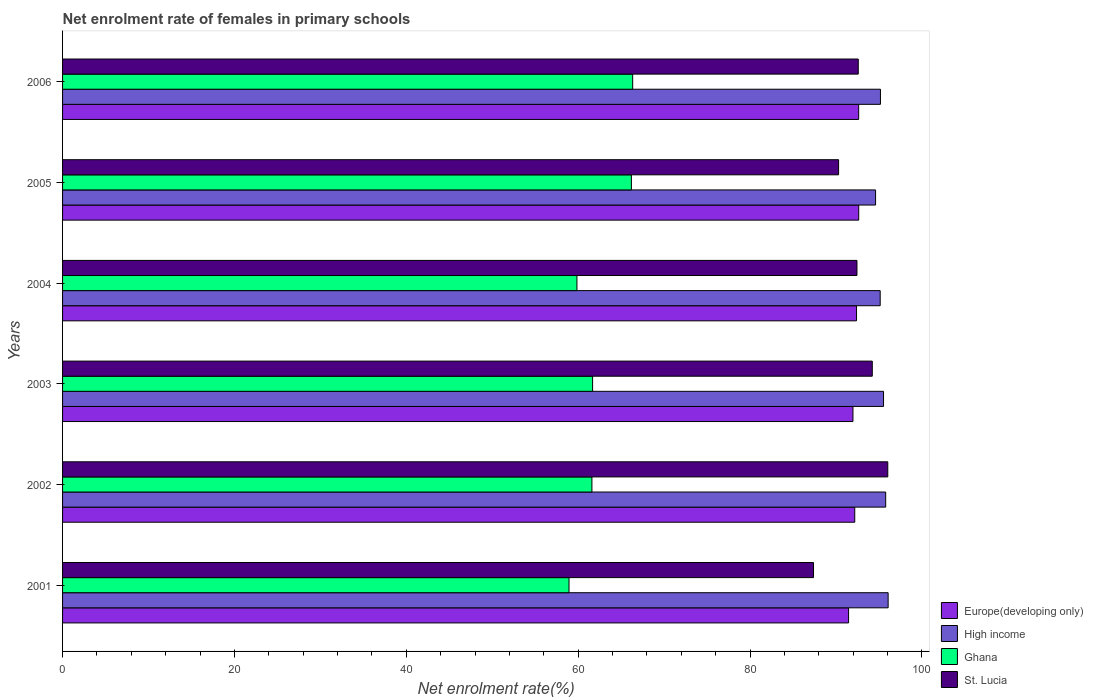How many different coloured bars are there?
Offer a very short reply. 4. Are the number of bars per tick equal to the number of legend labels?
Your answer should be compact. Yes. What is the net enrolment rate of females in primary schools in St. Lucia in 2004?
Ensure brevity in your answer.  92.44. Across all years, what is the maximum net enrolment rate of females in primary schools in High income?
Offer a very short reply. 96.07. Across all years, what is the minimum net enrolment rate of females in primary schools in High income?
Give a very brief answer. 94.61. In which year was the net enrolment rate of females in primary schools in Ghana maximum?
Give a very brief answer. 2006. In which year was the net enrolment rate of females in primary schools in Ghana minimum?
Give a very brief answer. 2001. What is the total net enrolment rate of females in primary schools in Europe(developing only) in the graph?
Provide a succinct answer. 553.29. What is the difference between the net enrolment rate of females in primary schools in Ghana in 2002 and that in 2004?
Ensure brevity in your answer.  1.74. What is the difference between the net enrolment rate of females in primary schools in Ghana in 2004 and the net enrolment rate of females in primary schools in St. Lucia in 2006?
Your answer should be compact. -32.74. What is the average net enrolment rate of females in primary schools in St. Lucia per year?
Offer a terse response. 92.16. In the year 2002, what is the difference between the net enrolment rate of females in primary schools in Ghana and net enrolment rate of females in primary schools in Europe(developing only)?
Provide a short and direct response. -30.58. In how many years, is the net enrolment rate of females in primary schools in Ghana greater than 64 %?
Make the answer very short. 2. What is the ratio of the net enrolment rate of females in primary schools in Europe(developing only) in 2002 to that in 2004?
Provide a short and direct response. 1. Is the net enrolment rate of females in primary schools in Europe(developing only) in 2004 less than that in 2005?
Ensure brevity in your answer.  Yes. Is the difference between the net enrolment rate of females in primary schools in Ghana in 2001 and 2003 greater than the difference between the net enrolment rate of females in primary schools in Europe(developing only) in 2001 and 2003?
Your response must be concise. No. What is the difference between the highest and the second highest net enrolment rate of females in primary schools in High income?
Offer a very short reply. 0.29. What is the difference between the highest and the lowest net enrolment rate of females in primary schools in Europe(developing only)?
Make the answer very short. 1.18. What does the 1st bar from the bottom in 2006 represents?
Offer a very short reply. Europe(developing only). Is it the case that in every year, the sum of the net enrolment rate of females in primary schools in Europe(developing only) and net enrolment rate of females in primary schools in St. Lucia is greater than the net enrolment rate of females in primary schools in Ghana?
Your answer should be compact. Yes. How many years are there in the graph?
Make the answer very short. 6. Does the graph contain any zero values?
Give a very brief answer. No. How many legend labels are there?
Make the answer very short. 4. How are the legend labels stacked?
Your answer should be very brief. Vertical. What is the title of the graph?
Give a very brief answer. Net enrolment rate of females in primary schools. Does "Bahrain" appear as one of the legend labels in the graph?
Keep it short and to the point. No. What is the label or title of the X-axis?
Your response must be concise. Net enrolment rate(%). What is the label or title of the Y-axis?
Offer a terse response. Years. What is the Net enrolment rate(%) of Europe(developing only) in 2001?
Ensure brevity in your answer.  91.46. What is the Net enrolment rate(%) of High income in 2001?
Your answer should be very brief. 96.07. What is the Net enrolment rate(%) in Ghana in 2001?
Ensure brevity in your answer.  58.93. What is the Net enrolment rate(%) of St. Lucia in 2001?
Offer a very short reply. 87.38. What is the Net enrolment rate(%) in Europe(developing only) in 2002?
Make the answer very short. 92.18. What is the Net enrolment rate(%) of High income in 2002?
Offer a very short reply. 95.78. What is the Net enrolment rate(%) of Ghana in 2002?
Give a very brief answer. 61.6. What is the Net enrolment rate(%) in St. Lucia in 2002?
Provide a short and direct response. 96.03. What is the Net enrolment rate(%) of Europe(developing only) in 2003?
Give a very brief answer. 91.97. What is the Net enrolment rate(%) of High income in 2003?
Give a very brief answer. 95.53. What is the Net enrolment rate(%) in Ghana in 2003?
Your answer should be very brief. 61.68. What is the Net enrolment rate(%) of St. Lucia in 2003?
Offer a terse response. 94.22. What is the Net enrolment rate(%) of Europe(developing only) in 2004?
Ensure brevity in your answer.  92.39. What is the Net enrolment rate(%) in High income in 2004?
Offer a very short reply. 95.14. What is the Net enrolment rate(%) of Ghana in 2004?
Keep it short and to the point. 59.85. What is the Net enrolment rate(%) in St. Lucia in 2004?
Offer a terse response. 92.44. What is the Net enrolment rate(%) of Europe(developing only) in 2005?
Give a very brief answer. 92.64. What is the Net enrolment rate(%) of High income in 2005?
Keep it short and to the point. 94.61. What is the Net enrolment rate(%) of Ghana in 2005?
Provide a short and direct response. 66.19. What is the Net enrolment rate(%) of St. Lucia in 2005?
Your answer should be very brief. 90.3. What is the Net enrolment rate(%) in Europe(developing only) in 2006?
Keep it short and to the point. 92.64. What is the Net enrolment rate(%) of High income in 2006?
Your answer should be compact. 95.17. What is the Net enrolment rate(%) of Ghana in 2006?
Your answer should be very brief. 66.34. What is the Net enrolment rate(%) of St. Lucia in 2006?
Offer a very short reply. 92.59. Across all years, what is the maximum Net enrolment rate(%) in Europe(developing only)?
Provide a short and direct response. 92.64. Across all years, what is the maximum Net enrolment rate(%) of High income?
Give a very brief answer. 96.07. Across all years, what is the maximum Net enrolment rate(%) of Ghana?
Provide a short and direct response. 66.34. Across all years, what is the maximum Net enrolment rate(%) in St. Lucia?
Keep it short and to the point. 96.03. Across all years, what is the minimum Net enrolment rate(%) in Europe(developing only)?
Provide a short and direct response. 91.46. Across all years, what is the minimum Net enrolment rate(%) in High income?
Your answer should be very brief. 94.61. Across all years, what is the minimum Net enrolment rate(%) of Ghana?
Your answer should be very brief. 58.93. Across all years, what is the minimum Net enrolment rate(%) in St. Lucia?
Keep it short and to the point. 87.38. What is the total Net enrolment rate(%) in Europe(developing only) in the graph?
Your answer should be compact. 553.29. What is the total Net enrolment rate(%) in High income in the graph?
Provide a succinct answer. 572.3. What is the total Net enrolment rate(%) of Ghana in the graph?
Offer a very short reply. 374.59. What is the total Net enrolment rate(%) in St. Lucia in the graph?
Provide a short and direct response. 552.96. What is the difference between the Net enrolment rate(%) in Europe(developing only) in 2001 and that in 2002?
Give a very brief answer. -0.72. What is the difference between the Net enrolment rate(%) of High income in 2001 and that in 2002?
Your answer should be very brief. 0.29. What is the difference between the Net enrolment rate(%) in Ghana in 2001 and that in 2002?
Make the answer very short. -2.67. What is the difference between the Net enrolment rate(%) in St. Lucia in 2001 and that in 2002?
Your answer should be very brief. -8.64. What is the difference between the Net enrolment rate(%) in Europe(developing only) in 2001 and that in 2003?
Give a very brief answer. -0.51. What is the difference between the Net enrolment rate(%) in High income in 2001 and that in 2003?
Offer a very short reply. 0.54. What is the difference between the Net enrolment rate(%) in Ghana in 2001 and that in 2003?
Your answer should be compact. -2.74. What is the difference between the Net enrolment rate(%) in St. Lucia in 2001 and that in 2003?
Make the answer very short. -6.84. What is the difference between the Net enrolment rate(%) of Europe(developing only) in 2001 and that in 2004?
Your response must be concise. -0.93. What is the difference between the Net enrolment rate(%) of High income in 2001 and that in 2004?
Ensure brevity in your answer.  0.93. What is the difference between the Net enrolment rate(%) in Ghana in 2001 and that in 2004?
Provide a succinct answer. -0.92. What is the difference between the Net enrolment rate(%) of St. Lucia in 2001 and that in 2004?
Ensure brevity in your answer.  -5.06. What is the difference between the Net enrolment rate(%) in Europe(developing only) in 2001 and that in 2005?
Make the answer very short. -1.18. What is the difference between the Net enrolment rate(%) of High income in 2001 and that in 2005?
Make the answer very short. 1.46. What is the difference between the Net enrolment rate(%) of Ghana in 2001 and that in 2005?
Your answer should be compact. -7.26. What is the difference between the Net enrolment rate(%) in St. Lucia in 2001 and that in 2005?
Your answer should be compact. -2.92. What is the difference between the Net enrolment rate(%) in Europe(developing only) in 2001 and that in 2006?
Provide a succinct answer. -1.18. What is the difference between the Net enrolment rate(%) in High income in 2001 and that in 2006?
Provide a short and direct response. 0.89. What is the difference between the Net enrolment rate(%) of Ghana in 2001 and that in 2006?
Your response must be concise. -7.41. What is the difference between the Net enrolment rate(%) of St. Lucia in 2001 and that in 2006?
Ensure brevity in your answer.  -5.21. What is the difference between the Net enrolment rate(%) in Europe(developing only) in 2002 and that in 2003?
Provide a short and direct response. 0.21. What is the difference between the Net enrolment rate(%) of High income in 2002 and that in 2003?
Provide a succinct answer. 0.25. What is the difference between the Net enrolment rate(%) in Ghana in 2002 and that in 2003?
Your response must be concise. -0.08. What is the difference between the Net enrolment rate(%) of St. Lucia in 2002 and that in 2003?
Provide a succinct answer. 1.8. What is the difference between the Net enrolment rate(%) in Europe(developing only) in 2002 and that in 2004?
Give a very brief answer. -0.21. What is the difference between the Net enrolment rate(%) in High income in 2002 and that in 2004?
Offer a very short reply. 0.64. What is the difference between the Net enrolment rate(%) in Ghana in 2002 and that in 2004?
Offer a terse response. 1.74. What is the difference between the Net enrolment rate(%) of St. Lucia in 2002 and that in 2004?
Keep it short and to the point. 3.59. What is the difference between the Net enrolment rate(%) of Europe(developing only) in 2002 and that in 2005?
Your answer should be very brief. -0.46. What is the difference between the Net enrolment rate(%) of High income in 2002 and that in 2005?
Your answer should be very brief. 1.18. What is the difference between the Net enrolment rate(%) of Ghana in 2002 and that in 2005?
Keep it short and to the point. -4.59. What is the difference between the Net enrolment rate(%) in St. Lucia in 2002 and that in 2005?
Offer a very short reply. 5.72. What is the difference between the Net enrolment rate(%) in Europe(developing only) in 2002 and that in 2006?
Keep it short and to the point. -0.46. What is the difference between the Net enrolment rate(%) in High income in 2002 and that in 2006?
Your answer should be very brief. 0.61. What is the difference between the Net enrolment rate(%) in Ghana in 2002 and that in 2006?
Provide a short and direct response. -4.74. What is the difference between the Net enrolment rate(%) in St. Lucia in 2002 and that in 2006?
Make the answer very short. 3.44. What is the difference between the Net enrolment rate(%) of Europe(developing only) in 2003 and that in 2004?
Give a very brief answer. -0.42. What is the difference between the Net enrolment rate(%) in High income in 2003 and that in 2004?
Provide a succinct answer. 0.39. What is the difference between the Net enrolment rate(%) of Ghana in 2003 and that in 2004?
Make the answer very short. 1.82. What is the difference between the Net enrolment rate(%) in St. Lucia in 2003 and that in 2004?
Provide a succinct answer. 1.78. What is the difference between the Net enrolment rate(%) in Europe(developing only) in 2003 and that in 2005?
Make the answer very short. -0.67. What is the difference between the Net enrolment rate(%) in High income in 2003 and that in 2005?
Keep it short and to the point. 0.92. What is the difference between the Net enrolment rate(%) of Ghana in 2003 and that in 2005?
Keep it short and to the point. -4.51. What is the difference between the Net enrolment rate(%) in St. Lucia in 2003 and that in 2005?
Offer a terse response. 3.92. What is the difference between the Net enrolment rate(%) of Europe(developing only) in 2003 and that in 2006?
Give a very brief answer. -0.67. What is the difference between the Net enrolment rate(%) in High income in 2003 and that in 2006?
Your answer should be very brief. 0.36. What is the difference between the Net enrolment rate(%) of Ghana in 2003 and that in 2006?
Provide a short and direct response. -4.66. What is the difference between the Net enrolment rate(%) of St. Lucia in 2003 and that in 2006?
Give a very brief answer. 1.63. What is the difference between the Net enrolment rate(%) in Europe(developing only) in 2004 and that in 2005?
Make the answer very short. -0.25. What is the difference between the Net enrolment rate(%) in High income in 2004 and that in 2005?
Ensure brevity in your answer.  0.54. What is the difference between the Net enrolment rate(%) of Ghana in 2004 and that in 2005?
Ensure brevity in your answer.  -6.34. What is the difference between the Net enrolment rate(%) in St. Lucia in 2004 and that in 2005?
Your answer should be compact. 2.14. What is the difference between the Net enrolment rate(%) of Europe(developing only) in 2004 and that in 2006?
Your response must be concise. -0.25. What is the difference between the Net enrolment rate(%) of High income in 2004 and that in 2006?
Offer a very short reply. -0.03. What is the difference between the Net enrolment rate(%) of Ghana in 2004 and that in 2006?
Offer a terse response. -6.49. What is the difference between the Net enrolment rate(%) in St. Lucia in 2004 and that in 2006?
Provide a succinct answer. -0.15. What is the difference between the Net enrolment rate(%) in Europe(developing only) in 2005 and that in 2006?
Keep it short and to the point. 0. What is the difference between the Net enrolment rate(%) of High income in 2005 and that in 2006?
Ensure brevity in your answer.  -0.57. What is the difference between the Net enrolment rate(%) in Ghana in 2005 and that in 2006?
Offer a terse response. -0.15. What is the difference between the Net enrolment rate(%) in St. Lucia in 2005 and that in 2006?
Make the answer very short. -2.29. What is the difference between the Net enrolment rate(%) of Europe(developing only) in 2001 and the Net enrolment rate(%) of High income in 2002?
Your answer should be compact. -4.32. What is the difference between the Net enrolment rate(%) of Europe(developing only) in 2001 and the Net enrolment rate(%) of Ghana in 2002?
Provide a short and direct response. 29.86. What is the difference between the Net enrolment rate(%) in Europe(developing only) in 2001 and the Net enrolment rate(%) in St. Lucia in 2002?
Provide a short and direct response. -4.56. What is the difference between the Net enrolment rate(%) of High income in 2001 and the Net enrolment rate(%) of Ghana in 2002?
Your answer should be compact. 34.47. What is the difference between the Net enrolment rate(%) in High income in 2001 and the Net enrolment rate(%) in St. Lucia in 2002?
Your response must be concise. 0.04. What is the difference between the Net enrolment rate(%) in Ghana in 2001 and the Net enrolment rate(%) in St. Lucia in 2002?
Your answer should be very brief. -37.09. What is the difference between the Net enrolment rate(%) in Europe(developing only) in 2001 and the Net enrolment rate(%) in High income in 2003?
Ensure brevity in your answer.  -4.07. What is the difference between the Net enrolment rate(%) of Europe(developing only) in 2001 and the Net enrolment rate(%) of Ghana in 2003?
Keep it short and to the point. 29.79. What is the difference between the Net enrolment rate(%) in Europe(developing only) in 2001 and the Net enrolment rate(%) in St. Lucia in 2003?
Your answer should be very brief. -2.76. What is the difference between the Net enrolment rate(%) in High income in 2001 and the Net enrolment rate(%) in Ghana in 2003?
Your answer should be compact. 34.39. What is the difference between the Net enrolment rate(%) in High income in 2001 and the Net enrolment rate(%) in St. Lucia in 2003?
Provide a short and direct response. 1.84. What is the difference between the Net enrolment rate(%) of Ghana in 2001 and the Net enrolment rate(%) of St. Lucia in 2003?
Provide a succinct answer. -35.29. What is the difference between the Net enrolment rate(%) in Europe(developing only) in 2001 and the Net enrolment rate(%) in High income in 2004?
Ensure brevity in your answer.  -3.68. What is the difference between the Net enrolment rate(%) in Europe(developing only) in 2001 and the Net enrolment rate(%) in Ghana in 2004?
Provide a short and direct response. 31.61. What is the difference between the Net enrolment rate(%) in Europe(developing only) in 2001 and the Net enrolment rate(%) in St. Lucia in 2004?
Your answer should be very brief. -0.98. What is the difference between the Net enrolment rate(%) in High income in 2001 and the Net enrolment rate(%) in Ghana in 2004?
Give a very brief answer. 36.21. What is the difference between the Net enrolment rate(%) of High income in 2001 and the Net enrolment rate(%) of St. Lucia in 2004?
Give a very brief answer. 3.63. What is the difference between the Net enrolment rate(%) of Ghana in 2001 and the Net enrolment rate(%) of St. Lucia in 2004?
Your answer should be compact. -33.51. What is the difference between the Net enrolment rate(%) in Europe(developing only) in 2001 and the Net enrolment rate(%) in High income in 2005?
Make the answer very short. -3.14. What is the difference between the Net enrolment rate(%) in Europe(developing only) in 2001 and the Net enrolment rate(%) in Ghana in 2005?
Give a very brief answer. 25.27. What is the difference between the Net enrolment rate(%) in Europe(developing only) in 2001 and the Net enrolment rate(%) in St. Lucia in 2005?
Provide a succinct answer. 1.16. What is the difference between the Net enrolment rate(%) of High income in 2001 and the Net enrolment rate(%) of Ghana in 2005?
Offer a very short reply. 29.88. What is the difference between the Net enrolment rate(%) of High income in 2001 and the Net enrolment rate(%) of St. Lucia in 2005?
Offer a terse response. 5.76. What is the difference between the Net enrolment rate(%) in Ghana in 2001 and the Net enrolment rate(%) in St. Lucia in 2005?
Make the answer very short. -31.37. What is the difference between the Net enrolment rate(%) of Europe(developing only) in 2001 and the Net enrolment rate(%) of High income in 2006?
Offer a terse response. -3.71. What is the difference between the Net enrolment rate(%) in Europe(developing only) in 2001 and the Net enrolment rate(%) in Ghana in 2006?
Keep it short and to the point. 25.12. What is the difference between the Net enrolment rate(%) of Europe(developing only) in 2001 and the Net enrolment rate(%) of St. Lucia in 2006?
Your response must be concise. -1.13. What is the difference between the Net enrolment rate(%) of High income in 2001 and the Net enrolment rate(%) of Ghana in 2006?
Your answer should be very brief. 29.73. What is the difference between the Net enrolment rate(%) in High income in 2001 and the Net enrolment rate(%) in St. Lucia in 2006?
Provide a short and direct response. 3.48. What is the difference between the Net enrolment rate(%) of Ghana in 2001 and the Net enrolment rate(%) of St. Lucia in 2006?
Give a very brief answer. -33.66. What is the difference between the Net enrolment rate(%) of Europe(developing only) in 2002 and the Net enrolment rate(%) of High income in 2003?
Your response must be concise. -3.35. What is the difference between the Net enrolment rate(%) of Europe(developing only) in 2002 and the Net enrolment rate(%) of Ghana in 2003?
Offer a terse response. 30.51. What is the difference between the Net enrolment rate(%) of Europe(developing only) in 2002 and the Net enrolment rate(%) of St. Lucia in 2003?
Give a very brief answer. -2.04. What is the difference between the Net enrolment rate(%) of High income in 2002 and the Net enrolment rate(%) of Ghana in 2003?
Your answer should be compact. 34.11. What is the difference between the Net enrolment rate(%) of High income in 2002 and the Net enrolment rate(%) of St. Lucia in 2003?
Make the answer very short. 1.56. What is the difference between the Net enrolment rate(%) in Ghana in 2002 and the Net enrolment rate(%) in St. Lucia in 2003?
Keep it short and to the point. -32.62. What is the difference between the Net enrolment rate(%) of Europe(developing only) in 2002 and the Net enrolment rate(%) of High income in 2004?
Provide a short and direct response. -2.96. What is the difference between the Net enrolment rate(%) of Europe(developing only) in 2002 and the Net enrolment rate(%) of Ghana in 2004?
Ensure brevity in your answer.  32.33. What is the difference between the Net enrolment rate(%) in Europe(developing only) in 2002 and the Net enrolment rate(%) in St. Lucia in 2004?
Offer a terse response. -0.26. What is the difference between the Net enrolment rate(%) in High income in 2002 and the Net enrolment rate(%) in Ghana in 2004?
Provide a short and direct response. 35.93. What is the difference between the Net enrolment rate(%) of High income in 2002 and the Net enrolment rate(%) of St. Lucia in 2004?
Offer a terse response. 3.34. What is the difference between the Net enrolment rate(%) of Ghana in 2002 and the Net enrolment rate(%) of St. Lucia in 2004?
Make the answer very short. -30.84. What is the difference between the Net enrolment rate(%) in Europe(developing only) in 2002 and the Net enrolment rate(%) in High income in 2005?
Ensure brevity in your answer.  -2.42. What is the difference between the Net enrolment rate(%) of Europe(developing only) in 2002 and the Net enrolment rate(%) of Ghana in 2005?
Provide a succinct answer. 25.99. What is the difference between the Net enrolment rate(%) of Europe(developing only) in 2002 and the Net enrolment rate(%) of St. Lucia in 2005?
Make the answer very short. 1.88. What is the difference between the Net enrolment rate(%) in High income in 2002 and the Net enrolment rate(%) in Ghana in 2005?
Your answer should be compact. 29.59. What is the difference between the Net enrolment rate(%) of High income in 2002 and the Net enrolment rate(%) of St. Lucia in 2005?
Offer a terse response. 5.48. What is the difference between the Net enrolment rate(%) of Ghana in 2002 and the Net enrolment rate(%) of St. Lucia in 2005?
Offer a terse response. -28.7. What is the difference between the Net enrolment rate(%) of Europe(developing only) in 2002 and the Net enrolment rate(%) of High income in 2006?
Offer a very short reply. -2.99. What is the difference between the Net enrolment rate(%) in Europe(developing only) in 2002 and the Net enrolment rate(%) in Ghana in 2006?
Your answer should be compact. 25.84. What is the difference between the Net enrolment rate(%) in Europe(developing only) in 2002 and the Net enrolment rate(%) in St. Lucia in 2006?
Your response must be concise. -0.41. What is the difference between the Net enrolment rate(%) of High income in 2002 and the Net enrolment rate(%) of Ghana in 2006?
Provide a succinct answer. 29.44. What is the difference between the Net enrolment rate(%) in High income in 2002 and the Net enrolment rate(%) in St. Lucia in 2006?
Offer a very short reply. 3.19. What is the difference between the Net enrolment rate(%) of Ghana in 2002 and the Net enrolment rate(%) of St. Lucia in 2006?
Keep it short and to the point. -30.99. What is the difference between the Net enrolment rate(%) in Europe(developing only) in 2003 and the Net enrolment rate(%) in High income in 2004?
Keep it short and to the point. -3.17. What is the difference between the Net enrolment rate(%) of Europe(developing only) in 2003 and the Net enrolment rate(%) of Ghana in 2004?
Provide a short and direct response. 32.12. What is the difference between the Net enrolment rate(%) of Europe(developing only) in 2003 and the Net enrolment rate(%) of St. Lucia in 2004?
Provide a short and direct response. -0.47. What is the difference between the Net enrolment rate(%) in High income in 2003 and the Net enrolment rate(%) in Ghana in 2004?
Ensure brevity in your answer.  35.68. What is the difference between the Net enrolment rate(%) of High income in 2003 and the Net enrolment rate(%) of St. Lucia in 2004?
Provide a short and direct response. 3.09. What is the difference between the Net enrolment rate(%) of Ghana in 2003 and the Net enrolment rate(%) of St. Lucia in 2004?
Offer a very short reply. -30.76. What is the difference between the Net enrolment rate(%) of Europe(developing only) in 2003 and the Net enrolment rate(%) of High income in 2005?
Keep it short and to the point. -2.63. What is the difference between the Net enrolment rate(%) of Europe(developing only) in 2003 and the Net enrolment rate(%) of Ghana in 2005?
Offer a very short reply. 25.78. What is the difference between the Net enrolment rate(%) of Europe(developing only) in 2003 and the Net enrolment rate(%) of St. Lucia in 2005?
Ensure brevity in your answer.  1.67. What is the difference between the Net enrolment rate(%) in High income in 2003 and the Net enrolment rate(%) in Ghana in 2005?
Your answer should be compact. 29.34. What is the difference between the Net enrolment rate(%) of High income in 2003 and the Net enrolment rate(%) of St. Lucia in 2005?
Your answer should be compact. 5.23. What is the difference between the Net enrolment rate(%) of Ghana in 2003 and the Net enrolment rate(%) of St. Lucia in 2005?
Provide a succinct answer. -28.63. What is the difference between the Net enrolment rate(%) in Europe(developing only) in 2003 and the Net enrolment rate(%) in High income in 2006?
Make the answer very short. -3.2. What is the difference between the Net enrolment rate(%) of Europe(developing only) in 2003 and the Net enrolment rate(%) of Ghana in 2006?
Ensure brevity in your answer.  25.63. What is the difference between the Net enrolment rate(%) in Europe(developing only) in 2003 and the Net enrolment rate(%) in St. Lucia in 2006?
Your response must be concise. -0.62. What is the difference between the Net enrolment rate(%) of High income in 2003 and the Net enrolment rate(%) of Ghana in 2006?
Ensure brevity in your answer.  29.19. What is the difference between the Net enrolment rate(%) in High income in 2003 and the Net enrolment rate(%) in St. Lucia in 2006?
Your response must be concise. 2.94. What is the difference between the Net enrolment rate(%) in Ghana in 2003 and the Net enrolment rate(%) in St. Lucia in 2006?
Give a very brief answer. -30.91. What is the difference between the Net enrolment rate(%) of Europe(developing only) in 2004 and the Net enrolment rate(%) of High income in 2005?
Offer a terse response. -2.22. What is the difference between the Net enrolment rate(%) of Europe(developing only) in 2004 and the Net enrolment rate(%) of Ghana in 2005?
Your response must be concise. 26.2. What is the difference between the Net enrolment rate(%) of Europe(developing only) in 2004 and the Net enrolment rate(%) of St. Lucia in 2005?
Your response must be concise. 2.09. What is the difference between the Net enrolment rate(%) of High income in 2004 and the Net enrolment rate(%) of Ghana in 2005?
Ensure brevity in your answer.  28.95. What is the difference between the Net enrolment rate(%) of High income in 2004 and the Net enrolment rate(%) of St. Lucia in 2005?
Keep it short and to the point. 4.84. What is the difference between the Net enrolment rate(%) in Ghana in 2004 and the Net enrolment rate(%) in St. Lucia in 2005?
Provide a succinct answer. -30.45. What is the difference between the Net enrolment rate(%) in Europe(developing only) in 2004 and the Net enrolment rate(%) in High income in 2006?
Provide a short and direct response. -2.78. What is the difference between the Net enrolment rate(%) of Europe(developing only) in 2004 and the Net enrolment rate(%) of Ghana in 2006?
Your response must be concise. 26.05. What is the difference between the Net enrolment rate(%) of Europe(developing only) in 2004 and the Net enrolment rate(%) of St. Lucia in 2006?
Make the answer very short. -0.2. What is the difference between the Net enrolment rate(%) in High income in 2004 and the Net enrolment rate(%) in Ghana in 2006?
Provide a succinct answer. 28.8. What is the difference between the Net enrolment rate(%) of High income in 2004 and the Net enrolment rate(%) of St. Lucia in 2006?
Keep it short and to the point. 2.55. What is the difference between the Net enrolment rate(%) of Ghana in 2004 and the Net enrolment rate(%) of St. Lucia in 2006?
Keep it short and to the point. -32.74. What is the difference between the Net enrolment rate(%) in Europe(developing only) in 2005 and the Net enrolment rate(%) in High income in 2006?
Your answer should be very brief. -2.53. What is the difference between the Net enrolment rate(%) of Europe(developing only) in 2005 and the Net enrolment rate(%) of Ghana in 2006?
Your answer should be compact. 26.3. What is the difference between the Net enrolment rate(%) of Europe(developing only) in 2005 and the Net enrolment rate(%) of St. Lucia in 2006?
Ensure brevity in your answer.  0.05. What is the difference between the Net enrolment rate(%) in High income in 2005 and the Net enrolment rate(%) in Ghana in 2006?
Ensure brevity in your answer.  28.27. What is the difference between the Net enrolment rate(%) of High income in 2005 and the Net enrolment rate(%) of St. Lucia in 2006?
Your response must be concise. 2.02. What is the difference between the Net enrolment rate(%) of Ghana in 2005 and the Net enrolment rate(%) of St. Lucia in 2006?
Offer a terse response. -26.4. What is the average Net enrolment rate(%) of Europe(developing only) per year?
Your answer should be compact. 92.21. What is the average Net enrolment rate(%) of High income per year?
Your response must be concise. 95.38. What is the average Net enrolment rate(%) in Ghana per year?
Provide a succinct answer. 62.43. What is the average Net enrolment rate(%) in St. Lucia per year?
Ensure brevity in your answer.  92.16. In the year 2001, what is the difference between the Net enrolment rate(%) in Europe(developing only) and Net enrolment rate(%) in High income?
Ensure brevity in your answer.  -4.6. In the year 2001, what is the difference between the Net enrolment rate(%) in Europe(developing only) and Net enrolment rate(%) in Ghana?
Provide a short and direct response. 32.53. In the year 2001, what is the difference between the Net enrolment rate(%) of Europe(developing only) and Net enrolment rate(%) of St. Lucia?
Make the answer very short. 4.08. In the year 2001, what is the difference between the Net enrolment rate(%) in High income and Net enrolment rate(%) in Ghana?
Ensure brevity in your answer.  37.13. In the year 2001, what is the difference between the Net enrolment rate(%) in High income and Net enrolment rate(%) in St. Lucia?
Offer a very short reply. 8.68. In the year 2001, what is the difference between the Net enrolment rate(%) in Ghana and Net enrolment rate(%) in St. Lucia?
Give a very brief answer. -28.45. In the year 2002, what is the difference between the Net enrolment rate(%) of Europe(developing only) and Net enrolment rate(%) of High income?
Your response must be concise. -3.6. In the year 2002, what is the difference between the Net enrolment rate(%) in Europe(developing only) and Net enrolment rate(%) in Ghana?
Offer a very short reply. 30.58. In the year 2002, what is the difference between the Net enrolment rate(%) of Europe(developing only) and Net enrolment rate(%) of St. Lucia?
Ensure brevity in your answer.  -3.84. In the year 2002, what is the difference between the Net enrolment rate(%) in High income and Net enrolment rate(%) in Ghana?
Give a very brief answer. 34.18. In the year 2002, what is the difference between the Net enrolment rate(%) in High income and Net enrolment rate(%) in St. Lucia?
Offer a terse response. -0.24. In the year 2002, what is the difference between the Net enrolment rate(%) of Ghana and Net enrolment rate(%) of St. Lucia?
Keep it short and to the point. -34.43. In the year 2003, what is the difference between the Net enrolment rate(%) in Europe(developing only) and Net enrolment rate(%) in High income?
Provide a succinct answer. -3.56. In the year 2003, what is the difference between the Net enrolment rate(%) in Europe(developing only) and Net enrolment rate(%) in Ghana?
Offer a terse response. 30.3. In the year 2003, what is the difference between the Net enrolment rate(%) in Europe(developing only) and Net enrolment rate(%) in St. Lucia?
Keep it short and to the point. -2.25. In the year 2003, what is the difference between the Net enrolment rate(%) in High income and Net enrolment rate(%) in Ghana?
Ensure brevity in your answer.  33.85. In the year 2003, what is the difference between the Net enrolment rate(%) of High income and Net enrolment rate(%) of St. Lucia?
Make the answer very short. 1.31. In the year 2003, what is the difference between the Net enrolment rate(%) in Ghana and Net enrolment rate(%) in St. Lucia?
Make the answer very short. -32.55. In the year 2004, what is the difference between the Net enrolment rate(%) in Europe(developing only) and Net enrolment rate(%) in High income?
Offer a very short reply. -2.75. In the year 2004, what is the difference between the Net enrolment rate(%) in Europe(developing only) and Net enrolment rate(%) in Ghana?
Give a very brief answer. 32.53. In the year 2004, what is the difference between the Net enrolment rate(%) in Europe(developing only) and Net enrolment rate(%) in St. Lucia?
Provide a succinct answer. -0.05. In the year 2004, what is the difference between the Net enrolment rate(%) of High income and Net enrolment rate(%) of Ghana?
Keep it short and to the point. 35.29. In the year 2004, what is the difference between the Net enrolment rate(%) in High income and Net enrolment rate(%) in St. Lucia?
Ensure brevity in your answer.  2.7. In the year 2004, what is the difference between the Net enrolment rate(%) in Ghana and Net enrolment rate(%) in St. Lucia?
Provide a succinct answer. -32.59. In the year 2005, what is the difference between the Net enrolment rate(%) of Europe(developing only) and Net enrolment rate(%) of High income?
Keep it short and to the point. -1.96. In the year 2005, what is the difference between the Net enrolment rate(%) in Europe(developing only) and Net enrolment rate(%) in Ghana?
Your answer should be very brief. 26.45. In the year 2005, what is the difference between the Net enrolment rate(%) in Europe(developing only) and Net enrolment rate(%) in St. Lucia?
Your response must be concise. 2.34. In the year 2005, what is the difference between the Net enrolment rate(%) of High income and Net enrolment rate(%) of Ghana?
Offer a very short reply. 28.42. In the year 2005, what is the difference between the Net enrolment rate(%) of High income and Net enrolment rate(%) of St. Lucia?
Offer a very short reply. 4.3. In the year 2005, what is the difference between the Net enrolment rate(%) of Ghana and Net enrolment rate(%) of St. Lucia?
Your response must be concise. -24.11. In the year 2006, what is the difference between the Net enrolment rate(%) in Europe(developing only) and Net enrolment rate(%) in High income?
Keep it short and to the point. -2.53. In the year 2006, what is the difference between the Net enrolment rate(%) of Europe(developing only) and Net enrolment rate(%) of Ghana?
Give a very brief answer. 26.3. In the year 2006, what is the difference between the Net enrolment rate(%) of Europe(developing only) and Net enrolment rate(%) of St. Lucia?
Make the answer very short. 0.05. In the year 2006, what is the difference between the Net enrolment rate(%) of High income and Net enrolment rate(%) of Ghana?
Provide a short and direct response. 28.83. In the year 2006, what is the difference between the Net enrolment rate(%) of High income and Net enrolment rate(%) of St. Lucia?
Your answer should be compact. 2.58. In the year 2006, what is the difference between the Net enrolment rate(%) of Ghana and Net enrolment rate(%) of St. Lucia?
Keep it short and to the point. -26.25. What is the ratio of the Net enrolment rate(%) of Europe(developing only) in 2001 to that in 2002?
Keep it short and to the point. 0.99. What is the ratio of the Net enrolment rate(%) of High income in 2001 to that in 2002?
Offer a very short reply. 1. What is the ratio of the Net enrolment rate(%) of Ghana in 2001 to that in 2002?
Ensure brevity in your answer.  0.96. What is the ratio of the Net enrolment rate(%) of St. Lucia in 2001 to that in 2002?
Your answer should be compact. 0.91. What is the ratio of the Net enrolment rate(%) in Europe(developing only) in 2001 to that in 2003?
Ensure brevity in your answer.  0.99. What is the ratio of the Net enrolment rate(%) in High income in 2001 to that in 2003?
Make the answer very short. 1.01. What is the ratio of the Net enrolment rate(%) of Ghana in 2001 to that in 2003?
Keep it short and to the point. 0.96. What is the ratio of the Net enrolment rate(%) in St. Lucia in 2001 to that in 2003?
Your answer should be compact. 0.93. What is the ratio of the Net enrolment rate(%) in High income in 2001 to that in 2004?
Provide a short and direct response. 1.01. What is the ratio of the Net enrolment rate(%) of Ghana in 2001 to that in 2004?
Keep it short and to the point. 0.98. What is the ratio of the Net enrolment rate(%) of St. Lucia in 2001 to that in 2004?
Your answer should be very brief. 0.95. What is the ratio of the Net enrolment rate(%) in Europe(developing only) in 2001 to that in 2005?
Make the answer very short. 0.99. What is the ratio of the Net enrolment rate(%) in High income in 2001 to that in 2005?
Offer a terse response. 1.02. What is the ratio of the Net enrolment rate(%) of Ghana in 2001 to that in 2005?
Provide a short and direct response. 0.89. What is the ratio of the Net enrolment rate(%) of St. Lucia in 2001 to that in 2005?
Keep it short and to the point. 0.97. What is the ratio of the Net enrolment rate(%) of Europe(developing only) in 2001 to that in 2006?
Offer a terse response. 0.99. What is the ratio of the Net enrolment rate(%) in High income in 2001 to that in 2006?
Offer a very short reply. 1.01. What is the ratio of the Net enrolment rate(%) in Ghana in 2001 to that in 2006?
Your response must be concise. 0.89. What is the ratio of the Net enrolment rate(%) of St. Lucia in 2001 to that in 2006?
Give a very brief answer. 0.94. What is the ratio of the Net enrolment rate(%) in St. Lucia in 2002 to that in 2003?
Offer a very short reply. 1.02. What is the ratio of the Net enrolment rate(%) in High income in 2002 to that in 2004?
Give a very brief answer. 1.01. What is the ratio of the Net enrolment rate(%) of Ghana in 2002 to that in 2004?
Keep it short and to the point. 1.03. What is the ratio of the Net enrolment rate(%) in St. Lucia in 2002 to that in 2004?
Your answer should be very brief. 1.04. What is the ratio of the Net enrolment rate(%) of High income in 2002 to that in 2005?
Your answer should be compact. 1.01. What is the ratio of the Net enrolment rate(%) of Ghana in 2002 to that in 2005?
Keep it short and to the point. 0.93. What is the ratio of the Net enrolment rate(%) of St. Lucia in 2002 to that in 2005?
Make the answer very short. 1.06. What is the ratio of the Net enrolment rate(%) in Europe(developing only) in 2002 to that in 2006?
Your answer should be compact. 1. What is the ratio of the Net enrolment rate(%) of High income in 2002 to that in 2006?
Your answer should be compact. 1.01. What is the ratio of the Net enrolment rate(%) in Ghana in 2002 to that in 2006?
Offer a terse response. 0.93. What is the ratio of the Net enrolment rate(%) of St. Lucia in 2002 to that in 2006?
Ensure brevity in your answer.  1.04. What is the ratio of the Net enrolment rate(%) of Ghana in 2003 to that in 2004?
Offer a terse response. 1.03. What is the ratio of the Net enrolment rate(%) in St. Lucia in 2003 to that in 2004?
Your answer should be very brief. 1.02. What is the ratio of the Net enrolment rate(%) in High income in 2003 to that in 2005?
Give a very brief answer. 1.01. What is the ratio of the Net enrolment rate(%) in Ghana in 2003 to that in 2005?
Your answer should be very brief. 0.93. What is the ratio of the Net enrolment rate(%) of St. Lucia in 2003 to that in 2005?
Offer a very short reply. 1.04. What is the ratio of the Net enrolment rate(%) in Europe(developing only) in 2003 to that in 2006?
Make the answer very short. 0.99. What is the ratio of the Net enrolment rate(%) of Ghana in 2003 to that in 2006?
Provide a succinct answer. 0.93. What is the ratio of the Net enrolment rate(%) of St. Lucia in 2003 to that in 2006?
Make the answer very short. 1.02. What is the ratio of the Net enrolment rate(%) in Europe(developing only) in 2004 to that in 2005?
Keep it short and to the point. 1. What is the ratio of the Net enrolment rate(%) in High income in 2004 to that in 2005?
Your answer should be very brief. 1.01. What is the ratio of the Net enrolment rate(%) of Ghana in 2004 to that in 2005?
Your answer should be compact. 0.9. What is the ratio of the Net enrolment rate(%) in St. Lucia in 2004 to that in 2005?
Make the answer very short. 1.02. What is the ratio of the Net enrolment rate(%) in Europe(developing only) in 2004 to that in 2006?
Your answer should be very brief. 1. What is the ratio of the Net enrolment rate(%) in High income in 2004 to that in 2006?
Provide a succinct answer. 1. What is the ratio of the Net enrolment rate(%) of Ghana in 2004 to that in 2006?
Offer a very short reply. 0.9. What is the ratio of the Net enrolment rate(%) of Ghana in 2005 to that in 2006?
Make the answer very short. 1. What is the ratio of the Net enrolment rate(%) in St. Lucia in 2005 to that in 2006?
Keep it short and to the point. 0.98. What is the difference between the highest and the second highest Net enrolment rate(%) of Europe(developing only)?
Make the answer very short. 0. What is the difference between the highest and the second highest Net enrolment rate(%) of High income?
Give a very brief answer. 0.29. What is the difference between the highest and the second highest Net enrolment rate(%) of Ghana?
Offer a terse response. 0.15. What is the difference between the highest and the second highest Net enrolment rate(%) of St. Lucia?
Ensure brevity in your answer.  1.8. What is the difference between the highest and the lowest Net enrolment rate(%) in Europe(developing only)?
Provide a short and direct response. 1.18. What is the difference between the highest and the lowest Net enrolment rate(%) of High income?
Give a very brief answer. 1.46. What is the difference between the highest and the lowest Net enrolment rate(%) of Ghana?
Give a very brief answer. 7.41. What is the difference between the highest and the lowest Net enrolment rate(%) of St. Lucia?
Your answer should be compact. 8.64. 